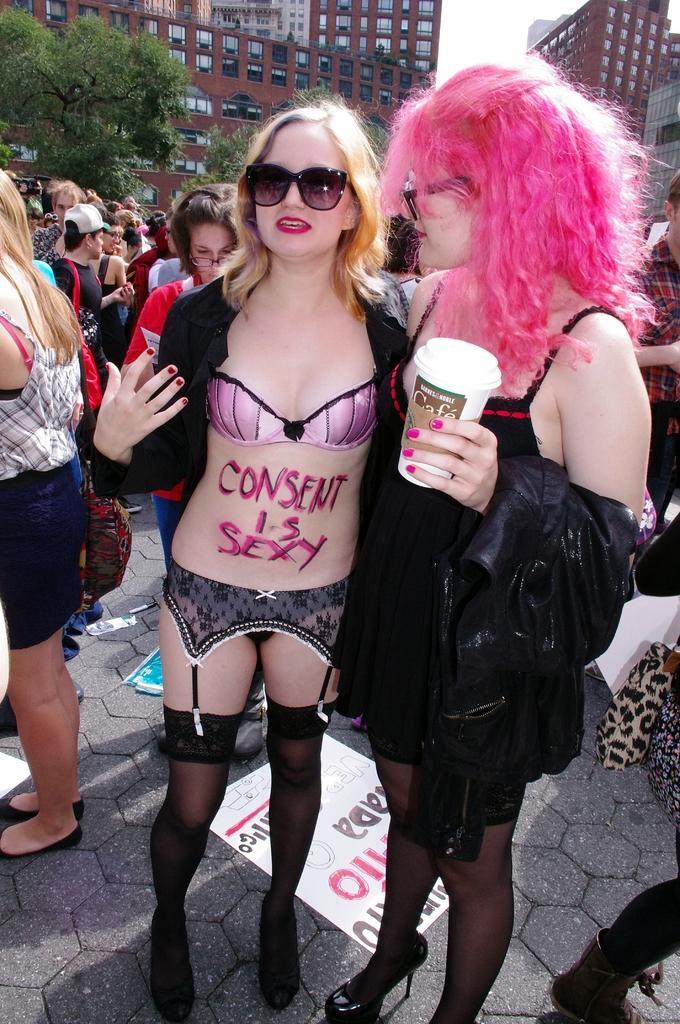Can you describe this image briefly? In the center of the image we can see two ladies standing. The lady standing on the right is holding a glass. In the background there are people, tree, buildings and sky. At the bottom there are papers on the road. 